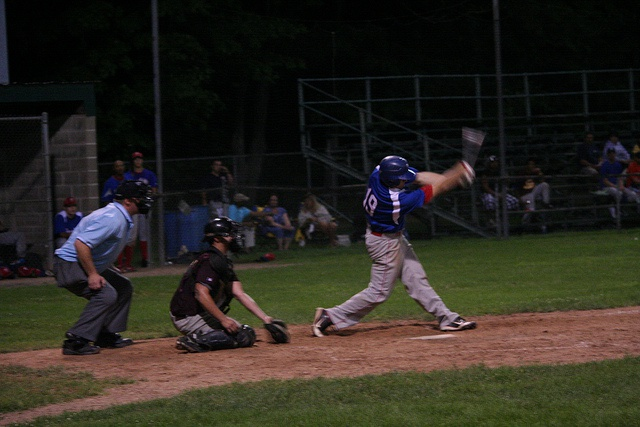Describe the objects in this image and their specific colors. I can see people in black and gray tones, people in black, darkgray, and gray tones, people in black, gray, brown, and maroon tones, people in black, navy, purple, and maroon tones, and people in black and purple tones in this image. 